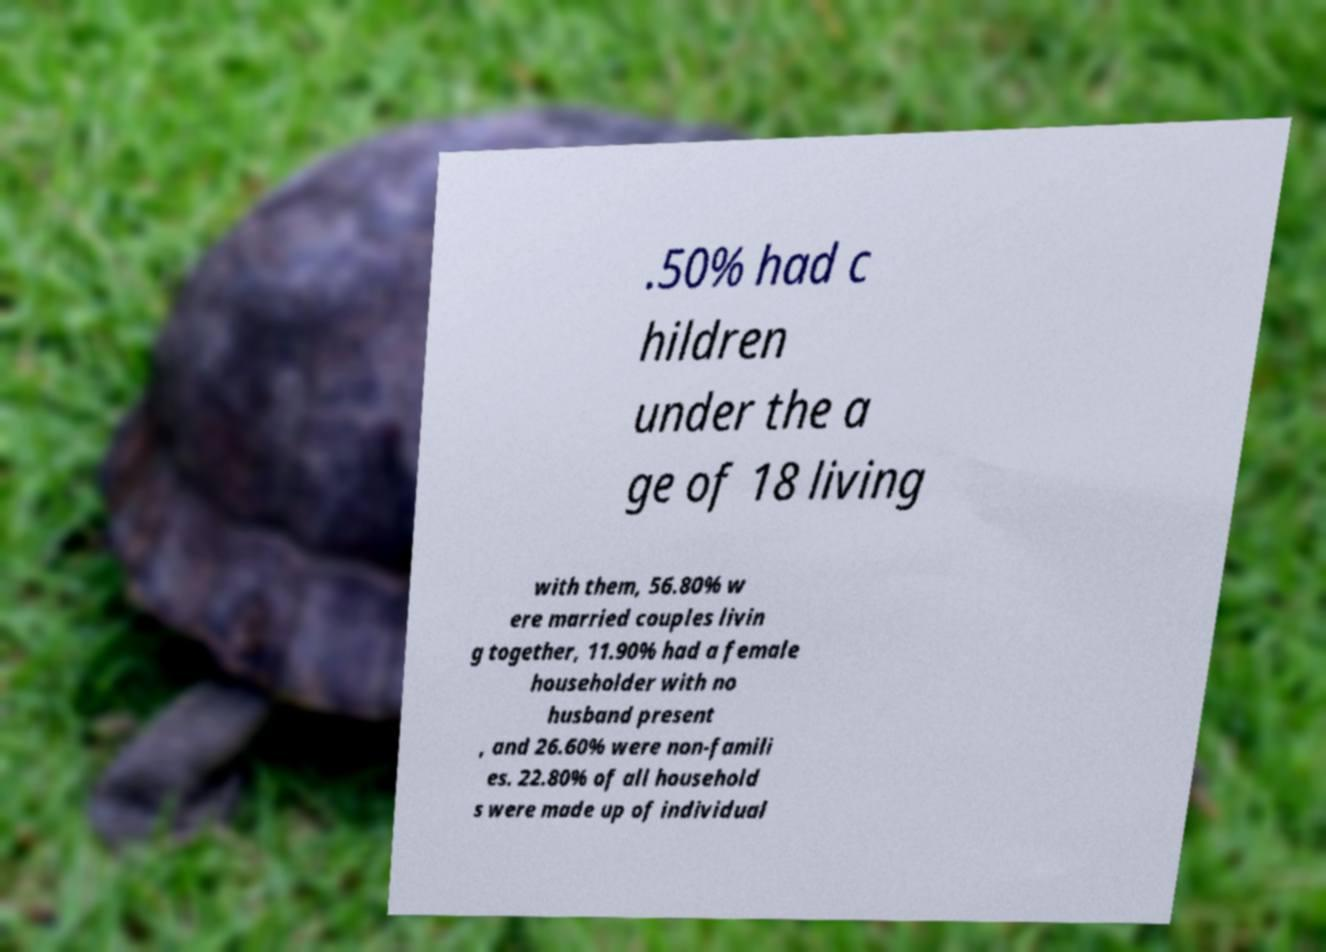There's text embedded in this image that I need extracted. Can you transcribe it verbatim? .50% had c hildren under the a ge of 18 living with them, 56.80% w ere married couples livin g together, 11.90% had a female householder with no husband present , and 26.60% were non-famili es. 22.80% of all household s were made up of individual 